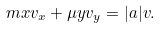Convert formula to latex. <formula><loc_0><loc_0><loc_500><loc_500>m x v _ { x } + \mu y v _ { y } = | a | v .</formula> 